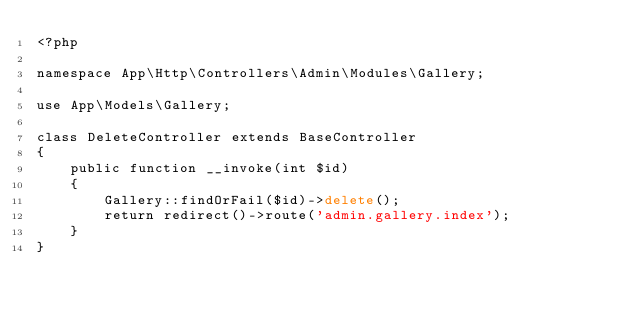Convert code to text. <code><loc_0><loc_0><loc_500><loc_500><_PHP_><?php

namespace App\Http\Controllers\Admin\Modules\Gallery;

use App\Models\Gallery;

class DeleteController extends BaseController
{
    public function __invoke(int $id)
    {
        Gallery::findOrFail($id)->delete();
        return redirect()->route('admin.gallery.index');
    }
}
</code> 